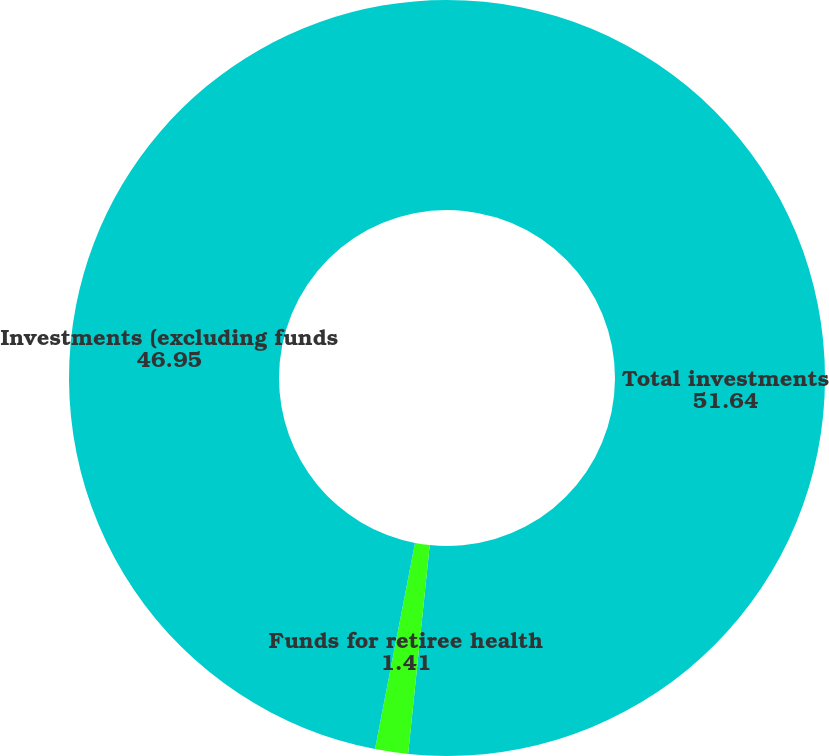Convert chart. <chart><loc_0><loc_0><loc_500><loc_500><pie_chart><fcel>Total investments<fcel>Funds for retiree health<fcel>Investments (excluding funds<nl><fcel>51.64%<fcel>1.41%<fcel>46.95%<nl></chart> 